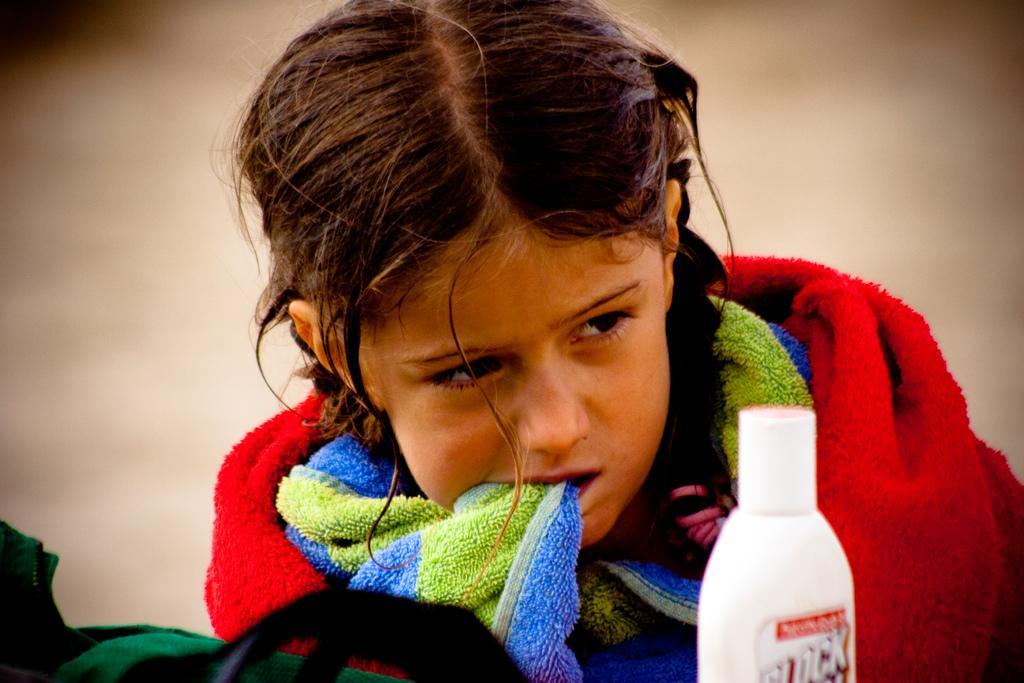How would you summarize this image in a sentence or two? This is a picture of a small girl who is covering a towel and there is white bottle in front of her and the towel is in red, blue and green in color. 